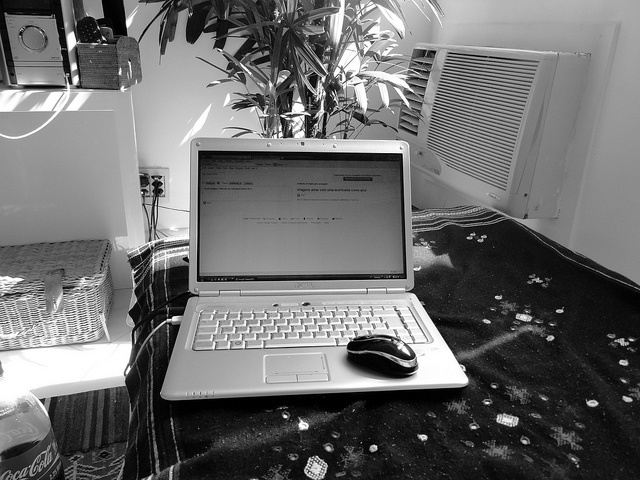Describe the objects in this image and their specific colors. I can see bed in black, gray, darkgray, and lightgray tones, laptop in black, darkgray, gray, and lightgray tones, potted plant in black, gray, darkgray, and lightgray tones, bottle in black, gray, and white tones, and mouse in black, gray, darkgray, and lightgray tones in this image. 